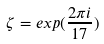<formula> <loc_0><loc_0><loc_500><loc_500>\zeta = e x p ( \frac { 2 \pi i } { 1 7 } )</formula> 